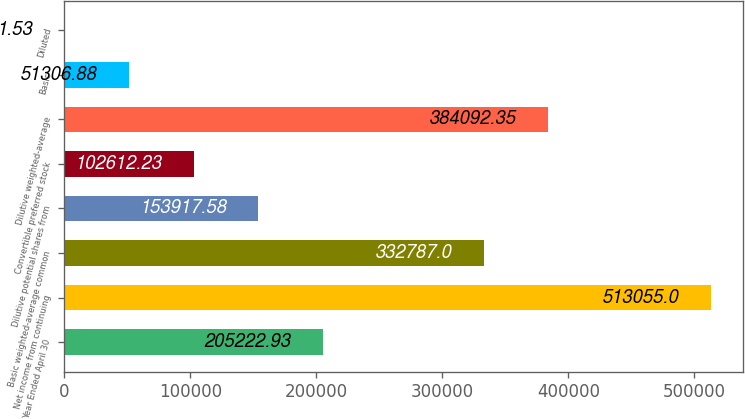Convert chart. <chart><loc_0><loc_0><loc_500><loc_500><bar_chart><fcel>Year Ended April 30<fcel>Net income from continuing<fcel>Basic weighted-average common<fcel>Dilutive potential shares from<fcel>Convertible preferred stock<fcel>Dilutive weighted-average<fcel>Basic<fcel>Diluted<nl><fcel>205223<fcel>513055<fcel>332787<fcel>153918<fcel>102612<fcel>384092<fcel>51306.9<fcel>1.53<nl></chart> 